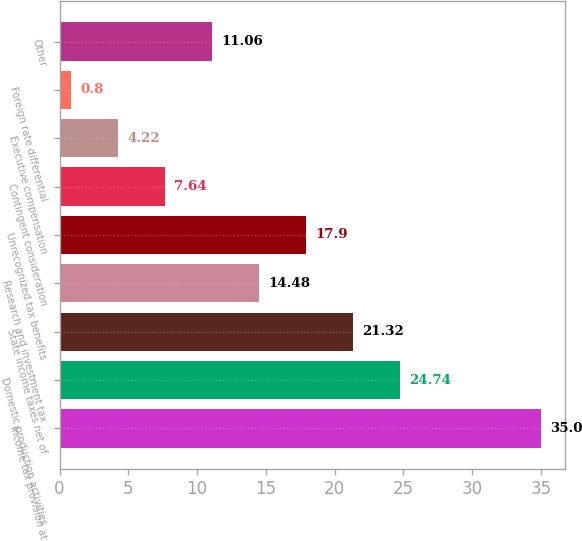Convert chart. <chart><loc_0><loc_0><loc_500><loc_500><bar_chart><fcel>Income tax provision at<fcel>Domestic production activities<fcel>State income taxes net of<fcel>Research and investment tax<fcel>Unrecognized tax benefits<fcel>Contingent consideration<fcel>Executive compensation<fcel>Foreign rate differential<fcel>Other<nl><fcel>35<fcel>24.74<fcel>21.32<fcel>14.48<fcel>17.9<fcel>7.64<fcel>4.22<fcel>0.8<fcel>11.06<nl></chart> 